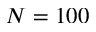<formula> <loc_0><loc_0><loc_500><loc_500>N = 1 0 0</formula> 